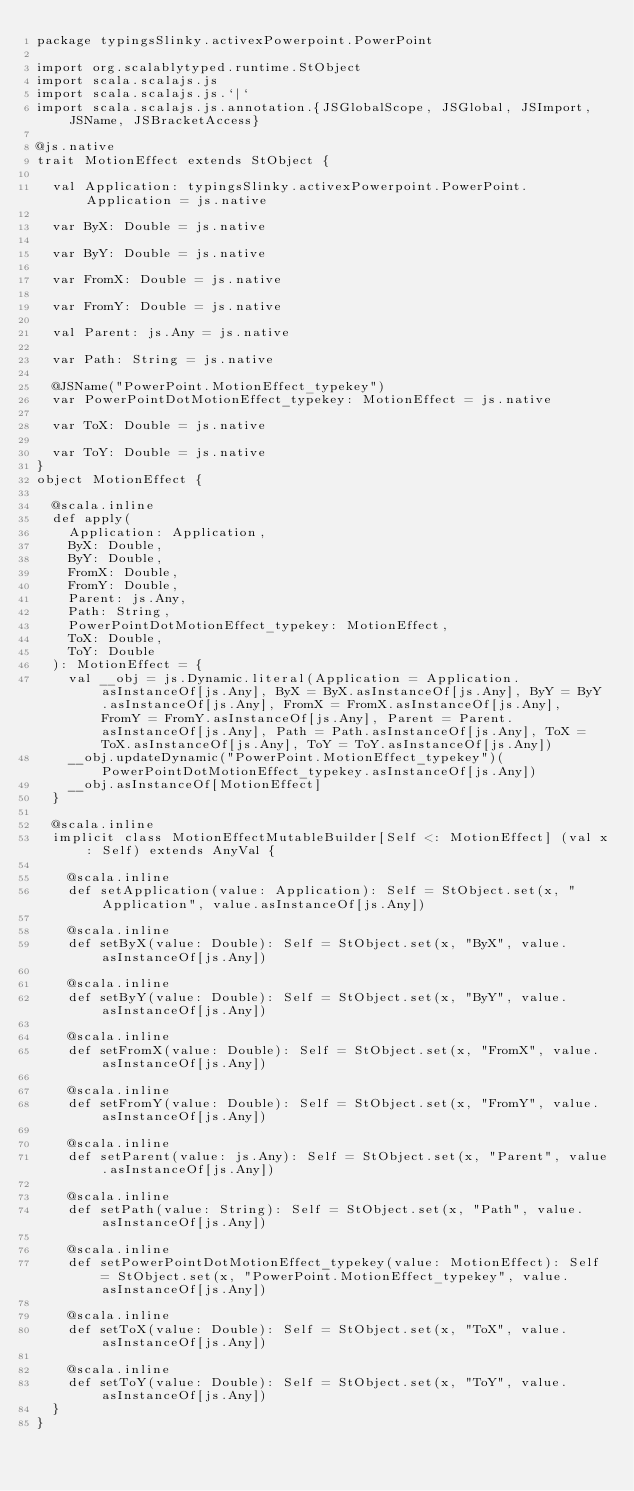Convert code to text. <code><loc_0><loc_0><loc_500><loc_500><_Scala_>package typingsSlinky.activexPowerpoint.PowerPoint

import org.scalablytyped.runtime.StObject
import scala.scalajs.js
import scala.scalajs.js.`|`
import scala.scalajs.js.annotation.{JSGlobalScope, JSGlobal, JSImport, JSName, JSBracketAccess}

@js.native
trait MotionEffect extends StObject {
  
  val Application: typingsSlinky.activexPowerpoint.PowerPoint.Application = js.native
  
  var ByX: Double = js.native
  
  var ByY: Double = js.native
  
  var FromX: Double = js.native
  
  var FromY: Double = js.native
  
  val Parent: js.Any = js.native
  
  var Path: String = js.native
  
  @JSName("PowerPoint.MotionEffect_typekey")
  var PowerPointDotMotionEffect_typekey: MotionEffect = js.native
  
  var ToX: Double = js.native
  
  var ToY: Double = js.native
}
object MotionEffect {
  
  @scala.inline
  def apply(
    Application: Application,
    ByX: Double,
    ByY: Double,
    FromX: Double,
    FromY: Double,
    Parent: js.Any,
    Path: String,
    PowerPointDotMotionEffect_typekey: MotionEffect,
    ToX: Double,
    ToY: Double
  ): MotionEffect = {
    val __obj = js.Dynamic.literal(Application = Application.asInstanceOf[js.Any], ByX = ByX.asInstanceOf[js.Any], ByY = ByY.asInstanceOf[js.Any], FromX = FromX.asInstanceOf[js.Any], FromY = FromY.asInstanceOf[js.Any], Parent = Parent.asInstanceOf[js.Any], Path = Path.asInstanceOf[js.Any], ToX = ToX.asInstanceOf[js.Any], ToY = ToY.asInstanceOf[js.Any])
    __obj.updateDynamic("PowerPoint.MotionEffect_typekey")(PowerPointDotMotionEffect_typekey.asInstanceOf[js.Any])
    __obj.asInstanceOf[MotionEffect]
  }
  
  @scala.inline
  implicit class MotionEffectMutableBuilder[Self <: MotionEffect] (val x: Self) extends AnyVal {
    
    @scala.inline
    def setApplication(value: Application): Self = StObject.set(x, "Application", value.asInstanceOf[js.Any])
    
    @scala.inline
    def setByX(value: Double): Self = StObject.set(x, "ByX", value.asInstanceOf[js.Any])
    
    @scala.inline
    def setByY(value: Double): Self = StObject.set(x, "ByY", value.asInstanceOf[js.Any])
    
    @scala.inline
    def setFromX(value: Double): Self = StObject.set(x, "FromX", value.asInstanceOf[js.Any])
    
    @scala.inline
    def setFromY(value: Double): Self = StObject.set(x, "FromY", value.asInstanceOf[js.Any])
    
    @scala.inline
    def setParent(value: js.Any): Self = StObject.set(x, "Parent", value.asInstanceOf[js.Any])
    
    @scala.inline
    def setPath(value: String): Self = StObject.set(x, "Path", value.asInstanceOf[js.Any])
    
    @scala.inline
    def setPowerPointDotMotionEffect_typekey(value: MotionEffect): Self = StObject.set(x, "PowerPoint.MotionEffect_typekey", value.asInstanceOf[js.Any])
    
    @scala.inline
    def setToX(value: Double): Self = StObject.set(x, "ToX", value.asInstanceOf[js.Any])
    
    @scala.inline
    def setToY(value: Double): Self = StObject.set(x, "ToY", value.asInstanceOf[js.Any])
  }
}
</code> 